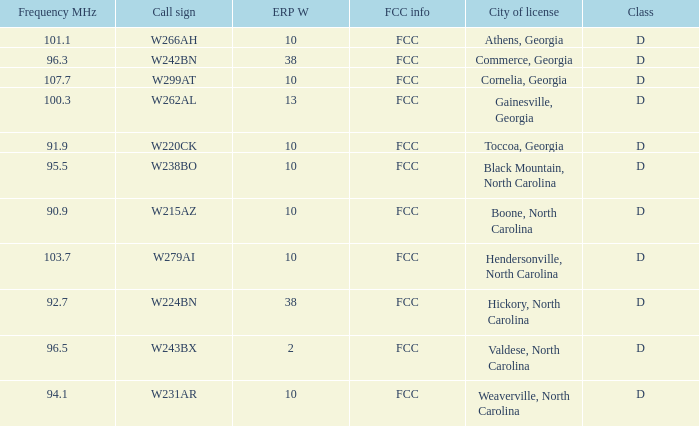What city has larger than 94.1 as a frequency? Athens, Georgia, Commerce, Georgia, Cornelia, Georgia, Gainesville, Georgia, Black Mountain, North Carolina, Hendersonville, North Carolina, Valdese, North Carolina. Write the full table. {'header': ['Frequency MHz', 'Call sign', 'ERP W', 'FCC info', 'City of license', 'Class'], 'rows': [['101.1', 'W266AH', '10', 'FCC', 'Athens, Georgia', 'D'], ['96.3', 'W242BN', '38', 'FCC', 'Commerce, Georgia', 'D'], ['107.7', 'W299AT', '10', 'FCC', 'Cornelia, Georgia', 'D'], ['100.3', 'W262AL', '13', 'FCC', 'Gainesville, Georgia', 'D'], ['91.9', 'W220CK', '10', 'FCC', 'Toccoa, Georgia', 'D'], ['95.5', 'W238BO', '10', 'FCC', 'Black Mountain, North Carolina', 'D'], ['90.9', 'W215AZ', '10', 'FCC', 'Boone, North Carolina', 'D'], ['103.7', 'W279AI', '10', 'FCC', 'Hendersonville, North Carolina', 'D'], ['92.7', 'W224BN', '38', 'FCC', 'Hickory, North Carolina', 'D'], ['96.5', 'W243BX', '2', 'FCC', 'Valdese, North Carolina', 'D'], ['94.1', 'W231AR', '10', 'FCC', 'Weaverville, North Carolina', 'D']]} 